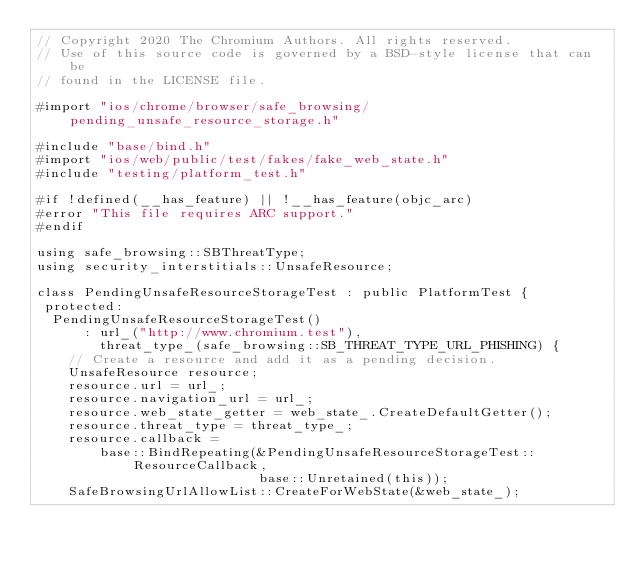<code> <loc_0><loc_0><loc_500><loc_500><_ObjectiveC_>// Copyright 2020 The Chromium Authors. All rights reserved.
// Use of this source code is governed by a BSD-style license that can be
// found in the LICENSE file.

#import "ios/chrome/browser/safe_browsing/pending_unsafe_resource_storage.h"

#include "base/bind.h"
#import "ios/web/public/test/fakes/fake_web_state.h"
#include "testing/platform_test.h"

#if !defined(__has_feature) || !__has_feature(objc_arc)
#error "This file requires ARC support."
#endif

using safe_browsing::SBThreatType;
using security_interstitials::UnsafeResource;

class PendingUnsafeResourceStorageTest : public PlatformTest {
 protected:
  PendingUnsafeResourceStorageTest()
      : url_("http://www.chromium.test"),
        threat_type_(safe_browsing::SB_THREAT_TYPE_URL_PHISHING) {
    // Create a resource and add it as a pending decision.
    UnsafeResource resource;
    resource.url = url_;
    resource.navigation_url = url_;
    resource.web_state_getter = web_state_.CreateDefaultGetter();
    resource.threat_type = threat_type_;
    resource.callback =
        base::BindRepeating(&PendingUnsafeResourceStorageTest::ResourceCallback,
                            base::Unretained(this));
    SafeBrowsingUrlAllowList::CreateForWebState(&web_state_);</code> 